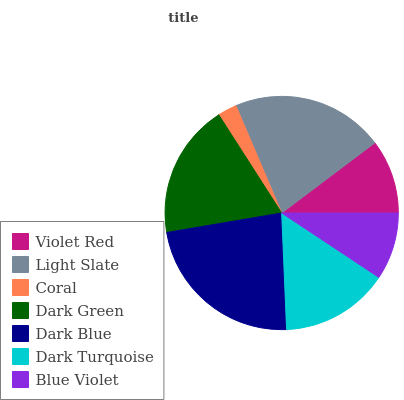Is Coral the minimum?
Answer yes or no. Yes. Is Dark Blue the maximum?
Answer yes or no. Yes. Is Light Slate the minimum?
Answer yes or no. No. Is Light Slate the maximum?
Answer yes or no. No. Is Light Slate greater than Violet Red?
Answer yes or no. Yes. Is Violet Red less than Light Slate?
Answer yes or no. Yes. Is Violet Red greater than Light Slate?
Answer yes or no. No. Is Light Slate less than Violet Red?
Answer yes or no. No. Is Dark Turquoise the high median?
Answer yes or no. Yes. Is Dark Turquoise the low median?
Answer yes or no. Yes. Is Dark Green the high median?
Answer yes or no. No. Is Blue Violet the low median?
Answer yes or no. No. 